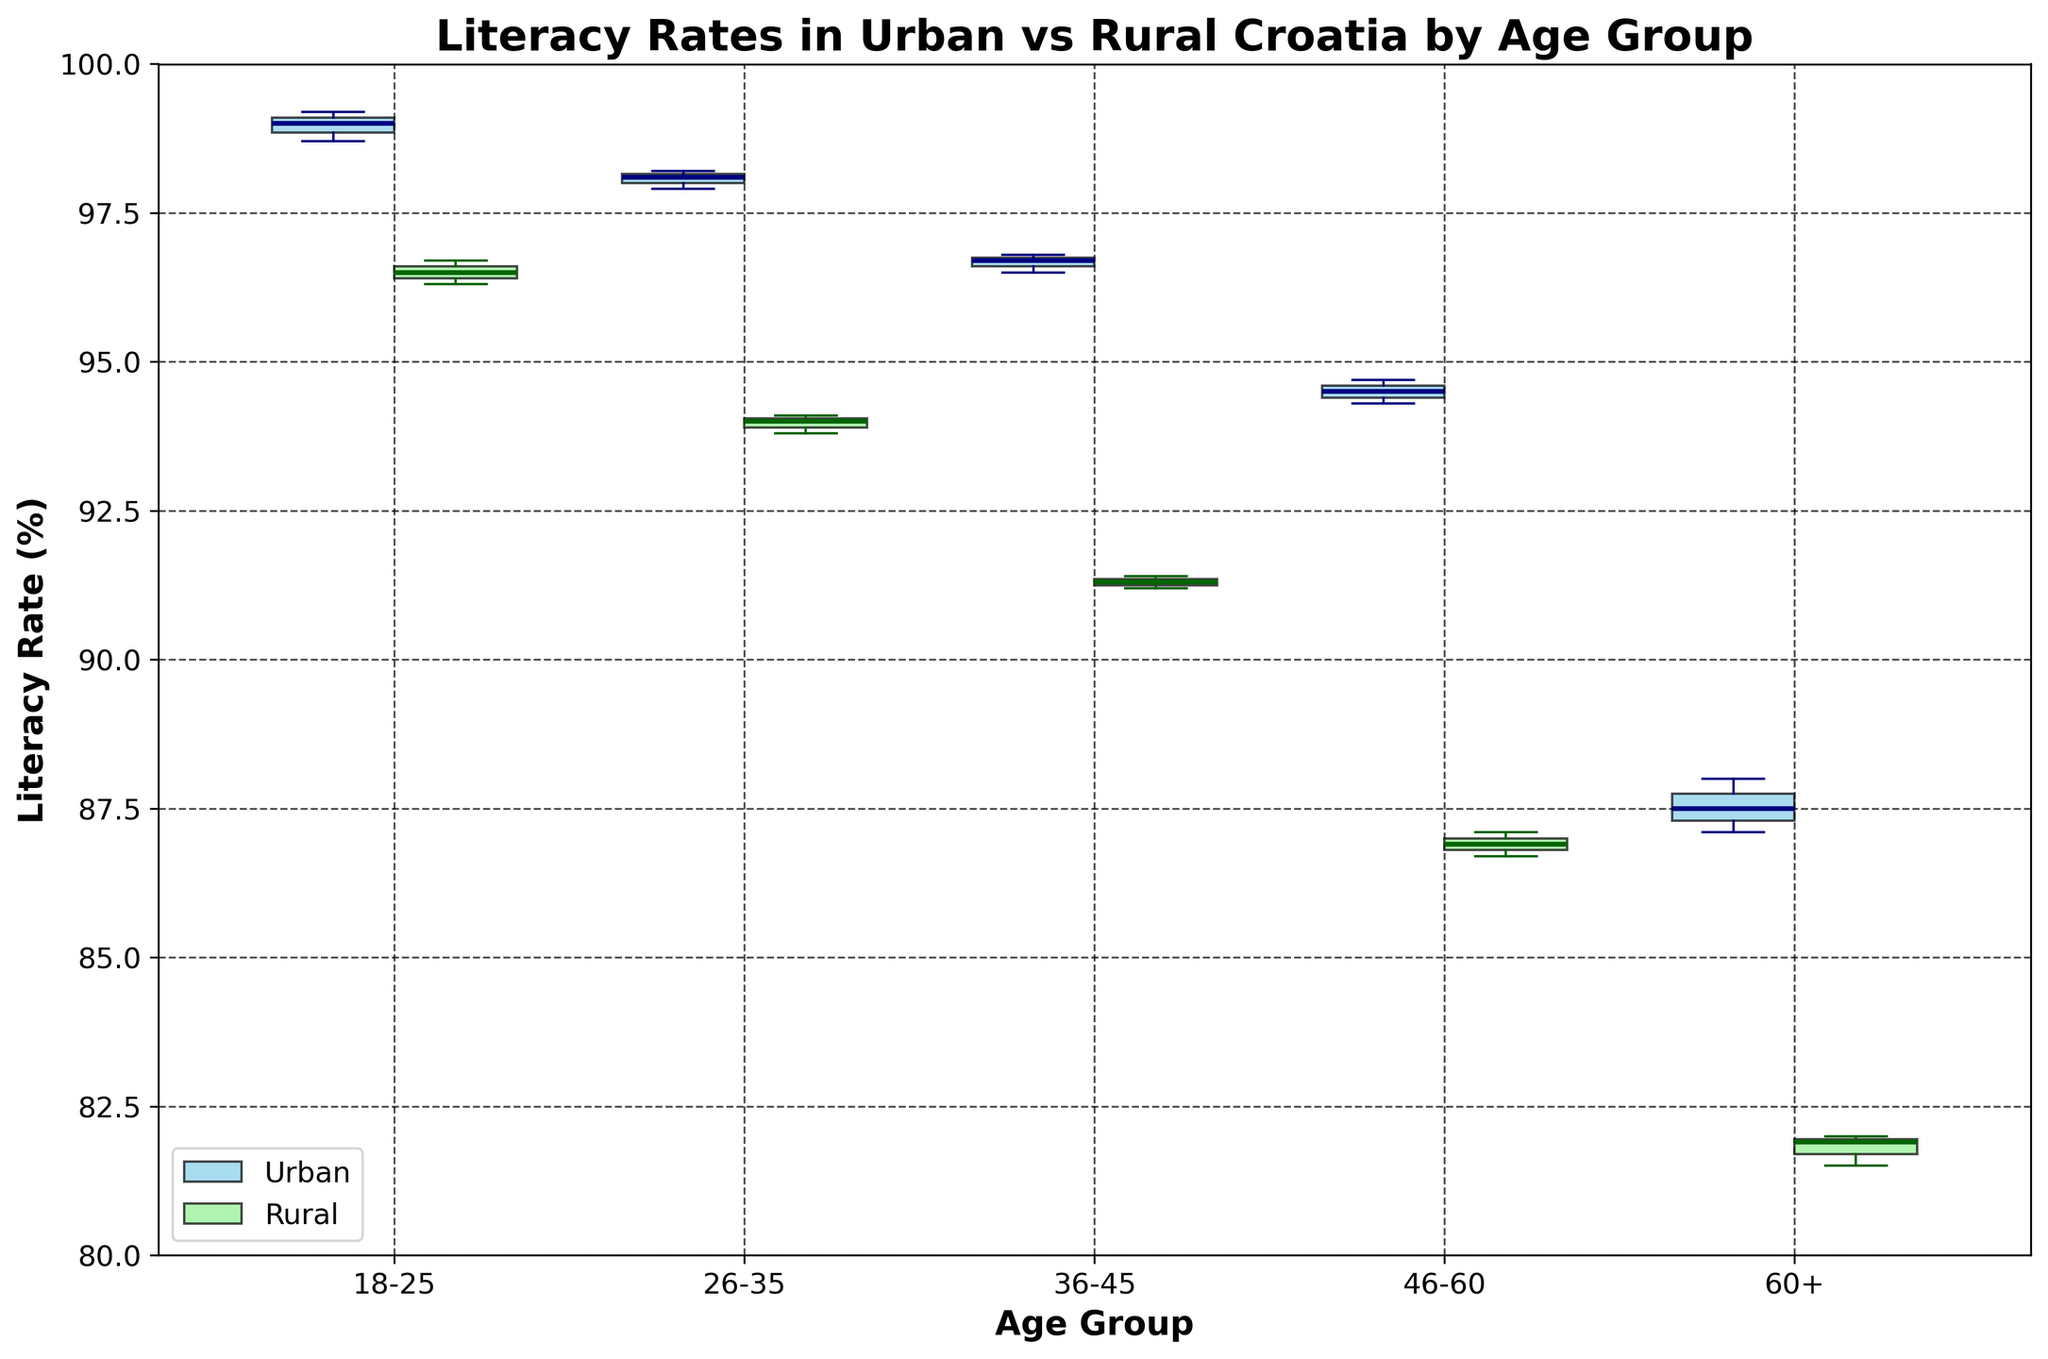What is the title of the figure? The title of the figure is prominently displayed at the top, providing an overview of the data being visualized.
Answer: Literacy Rates in Urban vs Rural Croatia by Age Group How many age groups are displayed in the figure? The x-axis labels represent the different age groups shown in the plot. Count the distinct labels.
Answer: 5 What are the two categories compared in the figure? The legend and the colors of the boxes help identify the two categories being compared.
Answer: Urban and Rural Which age group has the highest median literacy rate in Urban areas? Look at the line inside each box for the Urban category (sky blue) across age groups and find the highest one.
Answer: 18-25 Which age group has the lowest median literacy rate in Rural areas? Look at the line inside each box for the Rural category (light green) across age groups and find the lowest one.
Answer: 60+ What is the difference in the median literacy rate between Urban and Rural areas for the age group 36-45? Identify the median lines for both Urban (sky blue) and Rural (light green) boxes for the 36-45 age group and subtract the values.
Answer: 5.4% In which age group is the literacy rate the most variable for Rural areas? Assess the size of the box (interquartile range) for each age group in Rural areas (light green) to determine variability. Larger boxes indicate more variability.
Answer: 46-60 Is there any age group where the literacy rates of Urban and Rural areas are almost identical? Compare the medians of Urban and Rural areas across all age groups and find if any are very close to each other.
Answer: No Which category generally has a higher median literacy rate, Urban or Rural? Compare the median lines in the boxes of Urban and Rural categories across all age groups. More higher medians will indicate which category generally has a higher rate.
Answer: Urban 